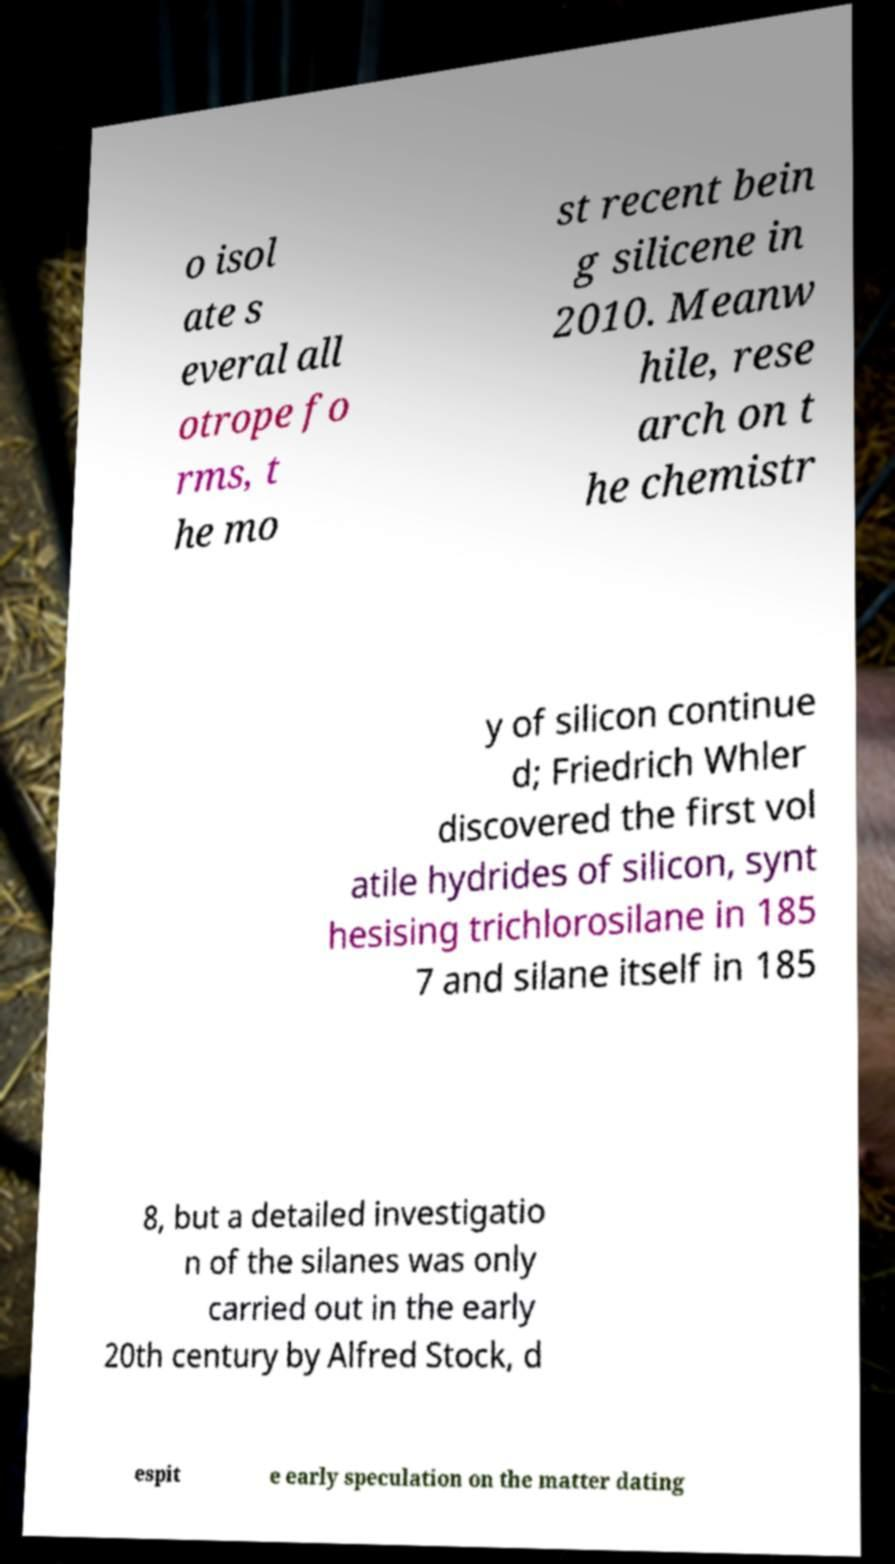Can you accurately transcribe the text from the provided image for me? o isol ate s everal all otrope fo rms, t he mo st recent bein g silicene in 2010. Meanw hile, rese arch on t he chemistr y of silicon continue d; Friedrich Whler discovered the first vol atile hydrides of silicon, synt hesising trichlorosilane in 185 7 and silane itself in 185 8, but a detailed investigatio n of the silanes was only carried out in the early 20th century by Alfred Stock, d espit e early speculation on the matter dating 